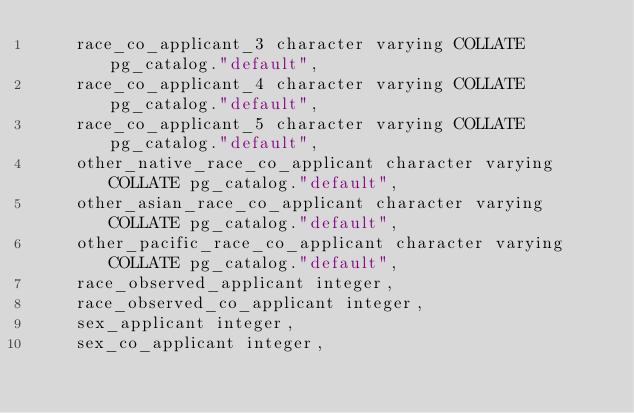<code> <loc_0><loc_0><loc_500><loc_500><_SQL_>    race_co_applicant_3 character varying COLLATE pg_catalog."default",
    race_co_applicant_4 character varying COLLATE pg_catalog."default",
    race_co_applicant_5 character varying COLLATE pg_catalog."default",
    other_native_race_co_applicant character varying COLLATE pg_catalog."default",
    other_asian_race_co_applicant character varying COLLATE pg_catalog."default",
    other_pacific_race_co_applicant character varying COLLATE pg_catalog."default",
    race_observed_applicant integer,
    race_observed_co_applicant integer,
    sex_applicant integer,
    sex_co_applicant integer,</code> 